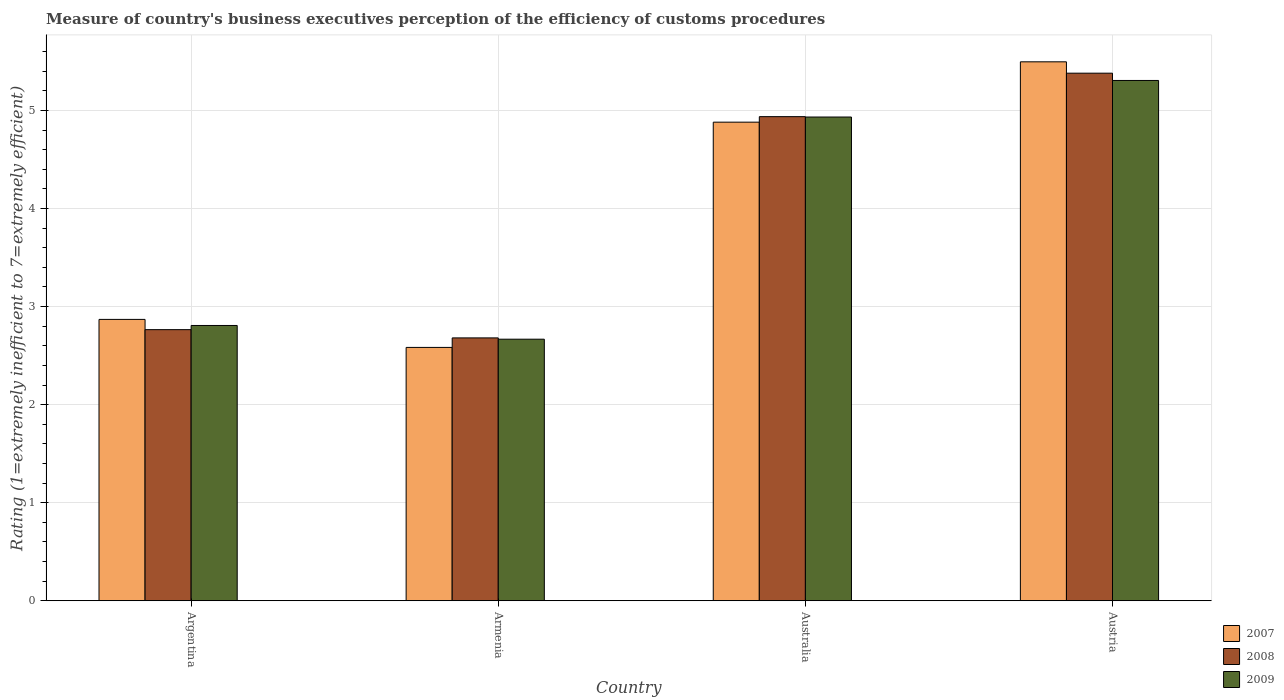How many groups of bars are there?
Give a very brief answer. 4. How many bars are there on the 4th tick from the left?
Ensure brevity in your answer.  3. How many bars are there on the 1st tick from the right?
Provide a succinct answer. 3. What is the label of the 2nd group of bars from the left?
Your answer should be compact. Armenia. What is the rating of the efficiency of customs procedure in 2009 in Austria?
Provide a succinct answer. 5.31. Across all countries, what is the maximum rating of the efficiency of customs procedure in 2008?
Your answer should be very brief. 5.38. Across all countries, what is the minimum rating of the efficiency of customs procedure in 2008?
Your answer should be compact. 2.68. In which country was the rating of the efficiency of customs procedure in 2008 maximum?
Provide a short and direct response. Austria. In which country was the rating of the efficiency of customs procedure in 2007 minimum?
Ensure brevity in your answer.  Armenia. What is the total rating of the efficiency of customs procedure in 2008 in the graph?
Ensure brevity in your answer.  15.76. What is the difference between the rating of the efficiency of customs procedure in 2008 in Argentina and that in Australia?
Ensure brevity in your answer.  -2.17. What is the difference between the rating of the efficiency of customs procedure in 2009 in Argentina and the rating of the efficiency of customs procedure in 2007 in Austria?
Ensure brevity in your answer.  -2.69. What is the average rating of the efficiency of customs procedure in 2008 per country?
Give a very brief answer. 3.94. What is the difference between the rating of the efficiency of customs procedure of/in 2007 and rating of the efficiency of customs procedure of/in 2009 in Armenia?
Your response must be concise. -0.08. What is the ratio of the rating of the efficiency of customs procedure in 2009 in Armenia to that in Austria?
Provide a succinct answer. 0.5. What is the difference between the highest and the second highest rating of the efficiency of customs procedure in 2008?
Offer a very short reply. -2.17. What is the difference between the highest and the lowest rating of the efficiency of customs procedure in 2007?
Make the answer very short. 2.91. In how many countries, is the rating of the efficiency of customs procedure in 2009 greater than the average rating of the efficiency of customs procedure in 2009 taken over all countries?
Make the answer very short. 2. What does the 3rd bar from the left in Armenia represents?
Ensure brevity in your answer.  2009. Does the graph contain any zero values?
Offer a very short reply. No. Does the graph contain grids?
Offer a very short reply. Yes. How many legend labels are there?
Offer a very short reply. 3. What is the title of the graph?
Keep it short and to the point. Measure of country's business executives perception of the efficiency of customs procedures. What is the label or title of the Y-axis?
Your answer should be very brief. Rating (1=extremely inefficient to 7=extremely efficient). What is the Rating (1=extremely inefficient to 7=extremely efficient) in 2007 in Argentina?
Your answer should be compact. 2.87. What is the Rating (1=extremely inefficient to 7=extremely efficient) of 2008 in Argentina?
Your answer should be very brief. 2.76. What is the Rating (1=extremely inefficient to 7=extremely efficient) of 2009 in Argentina?
Offer a terse response. 2.81. What is the Rating (1=extremely inefficient to 7=extremely efficient) of 2007 in Armenia?
Provide a short and direct response. 2.58. What is the Rating (1=extremely inefficient to 7=extremely efficient) of 2008 in Armenia?
Provide a succinct answer. 2.68. What is the Rating (1=extremely inefficient to 7=extremely efficient) in 2009 in Armenia?
Ensure brevity in your answer.  2.67. What is the Rating (1=extremely inefficient to 7=extremely efficient) of 2007 in Australia?
Your answer should be very brief. 4.88. What is the Rating (1=extremely inefficient to 7=extremely efficient) of 2008 in Australia?
Ensure brevity in your answer.  4.94. What is the Rating (1=extremely inefficient to 7=extremely efficient) in 2009 in Australia?
Give a very brief answer. 4.93. What is the Rating (1=extremely inefficient to 7=extremely efficient) in 2007 in Austria?
Your response must be concise. 5.5. What is the Rating (1=extremely inefficient to 7=extremely efficient) in 2008 in Austria?
Offer a terse response. 5.38. What is the Rating (1=extremely inefficient to 7=extremely efficient) in 2009 in Austria?
Provide a succinct answer. 5.31. Across all countries, what is the maximum Rating (1=extremely inefficient to 7=extremely efficient) in 2007?
Offer a terse response. 5.5. Across all countries, what is the maximum Rating (1=extremely inefficient to 7=extremely efficient) in 2008?
Make the answer very short. 5.38. Across all countries, what is the maximum Rating (1=extremely inefficient to 7=extremely efficient) in 2009?
Provide a succinct answer. 5.31. Across all countries, what is the minimum Rating (1=extremely inefficient to 7=extremely efficient) of 2007?
Ensure brevity in your answer.  2.58. Across all countries, what is the minimum Rating (1=extremely inefficient to 7=extremely efficient) in 2008?
Your response must be concise. 2.68. Across all countries, what is the minimum Rating (1=extremely inefficient to 7=extremely efficient) of 2009?
Offer a very short reply. 2.67. What is the total Rating (1=extremely inefficient to 7=extremely efficient) of 2007 in the graph?
Your answer should be compact. 15.83. What is the total Rating (1=extremely inefficient to 7=extremely efficient) of 2008 in the graph?
Keep it short and to the point. 15.76. What is the total Rating (1=extremely inefficient to 7=extremely efficient) of 2009 in the graph?
Offer a very short reply. 15.71. What is the difference between the Rating (1=extremely inefficient to 7=extremely efficient) of 2007 in Argentina and that in Armenia?
Give a very brief answer. 0.29. What is the difference between the Rating (1=extremely inefficient to 7=extremely efficient) of 2008 in Argentina and that in Armenia?
Offer a very short reply. 0.08. What is the difference between the Rating (1=extremely inefficient to 7=extremely efficient) of 2009 in Argentina and that in Armenia?
Ensure brevity in your answer.  0.14. What is the difference between the Rating (1=extremely inefficient to 7=extremely efficient) of 2007 in Argentina and that in Australia?
Give a very brief answer. -2.01. What is the difference between the Rating (1=extremely inefficient to 7=extremely efficient) of 2008 in Argentina and that in Australia?
Offer a terse response. -2.17. What is the difference between the Rating (1=extremely inefficient to 7=extremely efficient) in 2009 in Argentina and that in Australia?
Ensure brevity in your answer.  -2.13. What is the difference between the Rating (1=extremely inefficient to 7=extremely efficient) of 2007 in Argentina and that in Austria?
Provide a short and direct response. -2.63. What is the difference between the Rating (1=extremely inefficient to 7=extremely efficient) of 2008 in Argentina and that in Austria?
Make the answer very short. -2.62. What is the difference between the Rating (1=extremely inefficient to 7=extremely efficient) of 2009 in Argentina and that in Austria?
Provide a short and direct response. -2.5. What is the difference between the Rating (1=extremely inefficient to 7=extremely efficient) of 2007 in Armenia and that in Australia?
Your answer should be very brief. -2.3. What is the difference between the Rating (1=extremely inefficient to 7=extremely efficient) of 2008 in Armenia and that in Australia?
Offer a very short reply. -2.26. What is the difference between the Rating (1=extremely inefficient to 7=extremely efficient) in 2009 in Armenia and that in Australia?
Offer a very short reply. -2.27. What is the difference between the Rating (1=extremely inefficient to 7=extremely efficient) in 2007 in Armenia and that in Austria?
Offer a terse response. -2.91. What is the difference between the Rating (1=extremely inefficient to 7=extremely efficient) of 2008 in Armenia and that in Austria?
Ensure brevity in your answer.  -2.7. What is the difference between the Rating (1=extremely inefficient to 7=extremely efficient) of 2009 in Armenia and that in Austria?
Make the answer very short. -2.64. What is the difference between the Rating (1=extremely inefficient to 7=extremely efficient) in 2007 in Australia and that in Austria?
Keep it short and to the point. -0.62. What is the difference between the Rating (1=extremely inefficient to 7=extremely efficient) of 2008 in Australia and that in Austria?
Provide a short and direct response. -0.44. What is the difference between the Rating (1=extremely inefficient to 7=extremely efficient) of 2009 in Australia and that in Austria?
Provide a succinct answer. -0.37. What is the difference between the Rating (1=extremely inefficient to 7=extremely efficient) in 2007 in Argentina and the Rating (1=extremely inefficient to 7=extremely efficient) in 2008 in Armenia?
Provide a succinct answer. 0.19. What is the difference between the Rating (1=extremely inefficient to 7=extremely efficient) in 2007 in Argentina and the Rating (1=extremely inefficient to 7=extremely efficient) in 2009 in Armenia?
Your answer should be very brief. 0.2. What is the difference between the Rating (1=extremely inefficient to 7=extremely efficient) in 2008 in Argentina and the Rating (1=extremely inefficient to 7=extremely efficient) in 2009 in Armenia?
Offer a terse response. 0.1. What is the difference between the Rating (1=extremely inefficient to 7=extremely efficient) of 2007 in Argentina and the Rating (1=extremely inefficient to 7=extremely efficient) of 2008 in Australia?
Provide a short and direct response. -2.07. What is the difference between the Rating (1=extremely inefficient to 7=extremely efficient) of 2007 in Argentina and the Rating (1=extremely inefficient to 7=extremely efficient) of 2009 in Australia?
Your response must be concise. -2.06. What is the difference between the Rating (1=extremely inefficient to 7=extremely efficient) of 2008 in Argentina and the Rating (1=extremely inefficient to 7=extremely efficient) of 2009 in Australia?
Offer a very short reply. -2.17. What is the difference between the Rating (1=extremely inefficient to 7=extremely efficient) of 2007 in Argentina and the Rating (1=extremely inefficient to 7=extremely efficient) of 2008 in Austria?
Provide a succinct answer. -2.51. What is the difference between the Rating (1=extremely inefficient to 7=extremely efficient) in 2007 in Argentina and the Rating (1=extremely inefficient to 7=extremely efficient) in 2009 in Austria?
Your answer should be compact. -2.44. What is the difference between the Rating (1=extremely inefficient to 7=extremely efficient) of 2008 in Argentina and the Rating (1=extremely inefficient to 7=extremely efficient) of 2009 in Austria?
Keep it short and to the point. -2.54. What is the difference between the Rating (1=extremely inefficient to 7=extremely efficient) of 2007 in Armenia and the Rating (1=extremely inefficient to 7=extremely efficient) of 2008 in Australia?
Your answer should be very brief. -2.35. What is the difference between the Rating (1=extremely inefficient to 7=extremely efficient) in 2007 in Armenia and the Rating (1=extremely inefficient to 7=extremely efficient) in 2009 in Australia?
Keep it short and to the point. -2.35. What is the difference between the Rating (1=extremely inefficient to 7=extremely efficient) of 2008 in Armenia and the Rating (1=extremely inefficient to 7=extremely efficient) of 2009 in Australia?
Your response must be concise. -2.25. What is the difference between the Rating (1=extremely inefficient to 7=extremely efficient) in 2007 in Armenia and the Rating (1=extremely inefficient to 7=extremely efficient) in 2008 in Austria?
Offer a very short reply. -2.8. What is the difference between the Rating (1=extremely inefficient to 7=extremely efficient) in 2007 in Armenia and the Rating (1=extremely inefficient to 7=extremely efficient) in 2009 in Austria?
Provide a succinct answer. -2.72. What is the difference between the Rating (1=extremely inefficient to 7=extremely efficient) of 2008 in Armenia and the Rating (1=extremely inefficient to 7=extremely efficient) of 2009 in Austria?
Your response must be concise. -2.62. What is the difference between the Rating (1=extremely inefficient to 7=extremely efficient) in 2007 in Australia and the Rating (1=extremely inefficient to 7=extremely efficient) in 2008 in Austria?
Make the answer very short. -0.5. What is the difference between the Rating (1=extremely inefficient to 7=extremely efficient) of 2007 in Australia and the Rating (1=extremely inefficient to 7=extremely efficient) of 2009 in Austria?
Give a very brief answer. -0.43. What is the difference between the Rating (1=extremely inefficient to 7=extremely efficient) in 2008 in Australia and the Rating (1=extremely inefficient to 7=extremely efficient) in 2009 in Austria?
Your response must be concise. -0.37. What is the average Rating (1=extremely inefficient to 7=extremely efficient) in 2007 per country?
Give a very brief answer. 3.96. What is the average Rating (1=extremely inefficient to 7=extremely efficient) in 2008 per country?
Your response must be concise. 3.94. What is the average Rating (1=extremely inefficient to 7=extremely efficient) of 2009 per country?
Keep it short and to the point. 3.93. What is the difference between the Rating (1=extremely inefficient to 7=extremely efficient) in 2007 and Rating (1=extremely inefficient to 7=extremely efficient) in 2008 in Argentina?
Offer a very short reply. 0.1. What is the difference between the Rating (1=extremely inefficient to 7=extremely efficient) in 2007 and Rating (1=extremely inefficient to 7=extremely efficient) in 2009 in Argentina?
Your response must be concise. 0.06. What is the difference between the Rating (1=extremely inefficient to 7=extremely efficient) of 2008 and Rating (1=extremely inefficient to 7=extremely efficient) of 2009 in Argentina?
Your answer should be very brief. -0.04. What is the difference between the Rating (1=extremely inefficient to 7=extremely efficient) in 2007 and Rating (1=extremely inefficient to 7=extremely efficient) in 2008 in Armenia?
Your answer should be very brief. -0.1. What is the difference between the Rating (1=extremely inefficient to 7=extremely efficient) in 2007 and Rating (1=extremely inefficient to 7=extremely efficient) in 2009 in Armenia?
Your answer should be compact. -0.08. What is the difference between the Rating (1=extremely inefficient to 7=extremely efficient) of 2008 and Rating (1=extremely inefficient to 7=extremely efficient) of 2009 in Armenia?
Give a very brief answer. 0.01. What is the difference between the Rating (1=extremely inefficient to 7=extremely efficient) in 2007 and Rating (1=extremely inefficient to 7=extremely efficient) in 2008 in Australia?
Your response must be concise. -0.06. What is the difference between the Rating (1=extremely inefficient to 7=extremely efficient) in 2007 and Rating (1=extremely inefficient to 7=extremely efficient) in 2009 in Australia?
Your answer should be compact. -0.05. What is the difference between the Rating (1=extremely inefficient to 7=extremely efficient) in 2008 and Rating (1=extremely inefficient to 7=extremely efficient) in 2009 in Australia?
Your response must be concise. 0. What is the difference between the Rating (1=extremely inefficient to 7=extremely efficient) in 2007 and Rating (1=extremely inefficient to 7=extremely efficient) in 2008 in Austria?
Ensure brevity in your answer.  0.12. What is the difference between the Rating (1=extremely inefficient to 7=extremely efficient) in 2007 and Rating (1=extremely inefficient to 7=extremely efficient) in 2009 in Austria?
Your answer should be compact. 0.19. What is the difference between the Rating (1=extremely inefficient to 7=extremely efficient) of 2008 and Rating (1=extremely inefficient to 7=extremely efficient) of 2009 in Austria?
Offer a terse response. 0.07. What is the ratio of the Rating (1=extremely inefficient to 7=extremely efficient) in 2007 in Argentina to that in Armenia?
Offer a very short reply. 1.11. What is the ratio of the Rating (1=extremely inefficient to 7=extremely efficient) of 2008 in Argentina to that in Armenia?
Your answer should be very brief. 1.03. What is the ratio of the Rating (1=extremely inefficient to 7=extremely efficient) of 2009 in Argentina to that in Armenia?
Ensure brevity in your answer.  1.05. What is the ratio of the Rating (1=extremely inefficient to 7=extremely efficient) in 2007 in Argentina to that in Australia?
Make the answer very short. 0.59. What is the ratio of the Rating (1=extremely inefficient to 7=extremely efficient) in 2008 in Argentina to that in Australia?
Provide a succinct answer. 0.56. What is the ratio of the Rating (1=extremely inefficient to 7=extremely efficient) in 2009 in Argentina to that in Australia?
Make the answer very short. 0.57. What is the ratio of the Rating (1=extremely inefficient to 7=extremely efficient) of 2007 in Argentina to that in Austria?
Your response must be concise. 0.52. What is the ratio of the Rating (1=extremely inefficient to 7=extremely efficient) in 2008 in Argentina to that in Austria?
Keep it short and to the point. 0.51. What is the ratio of the Rating (1=extremely inefficient to 7=extremely efficient) in 2009 in Argentina to that in Austria?
Ensure brevity in your answer.  0.53. What is the ratio of the Rating (1=extremely inefficient to 7=extremely efficient) of 2007 in Armenia to that in Australia?
Your answer should be very brief. 0.53. What is the ratio of the Rating (1=extremely inefficient to 7=extremely efficient) of 2008 in Armenia to that in Australia?
Give a very brief answer. 0.54. What is the ratio of the Rating (1=extremely inefficient to 7=extremely efficient) in 2009 in Armenia to that in Australia?
Offer a terse response. 0.54. What is the ratio of the Rating (1=extremely inefficient to 7=extremely efficient) in 2007 in Armenia to that in Austria?
Your answer should be compact. 0.47. What is the ratio of the Rating (1=extremely inefficient to 7=extremely efficient) of 2008 in Armenia to that in Austria?
Your answer should be very brief. 0.5. What is the ratio of the Rating (1=extremely inefficient to 7=extremely efficient) of 2009 in Armenia to that in Austria?
Provide a short and direct response. 0.5. What is the ratio of the Rating (1=extremely inefficient to 7=extremely efficient) of 2007 in Australia to that in Austria?
Ensure brevity in your answer.  0.89. What is the ratio of the Rating (1=extremely inefficient to 7=extremely efficient) of 2008 in Australia to that in Austria?
Give a very brief answer. 0.92. What is the ratio of the Rating (1=extremely inefficient to 7=extremely efficient) of 2009 in Australia to that in Austria?
Your answer should be compact. 0.93. What is the difference between the highest and the second highest Rating (1=extremely inefficient to 7=extremely efficient) in 2007?
Your response must be concise. 0.62. What is the difference between the highest and the second highest Rating (1=extremely inefficient to 7=extremely efficient) in 2008?
Give a very brief answer. 0.44. What is the difference between the highest and the second highest Rating (1=extremely inefficient to 7=extremely efficient) of 2009?
Make the answer very short. 0.37. What is the difference between the highest and the lowest Rating (1=extremely inefficient to 7=extremely efficient) of 2007?
Ensure brevity in your answer.  2.91. What is the difference between the highest and the lowest Rating (1=extremely inefficient to 7=extremely efficient) in 2008?
Your answer should be very brief. 2.7. What is the difference between the highest and the lowest Rating (1=extremely inefficient to 7=extremely efficient) in 2009?
Offer a very short reply. 2.64. 